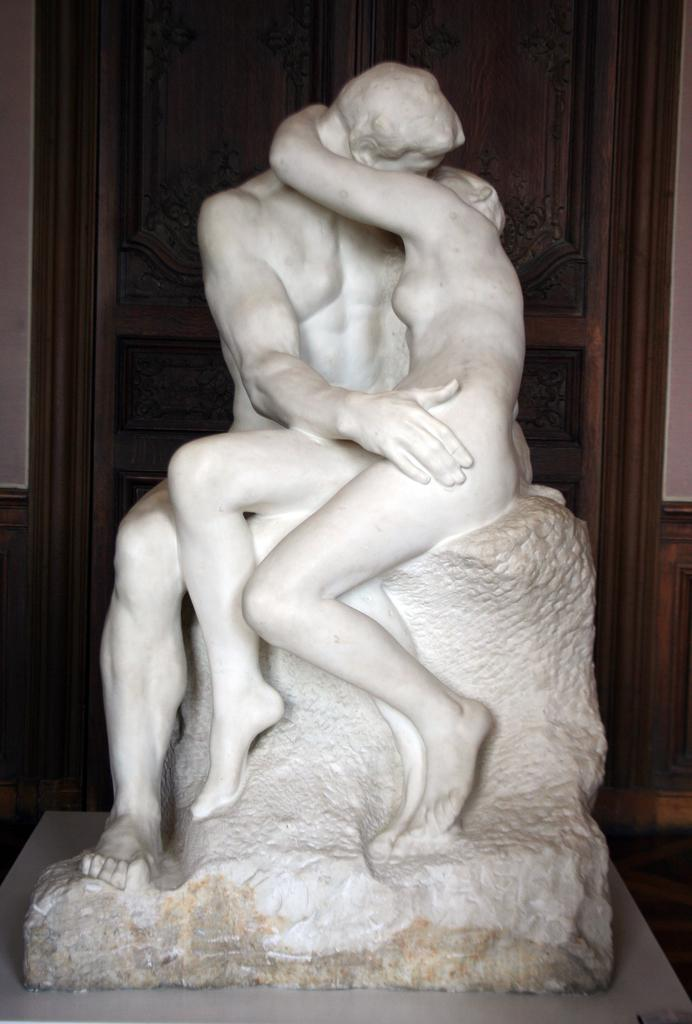What type of figures are present in the image? There are human statues in the image. Where are the statues located? The statues are sitting on a rock. What can be seen in the background of the image? There is a door visible in the background of the image. What type of quartz can be seen in the hands of the statues? There is no quartz present in the image; the statues are not holding any objects. Can you tell me the name of the porter who is guiding the statues in the image? There is no porter or guide present in the image, as the statues are not moving or being led by anyone. 